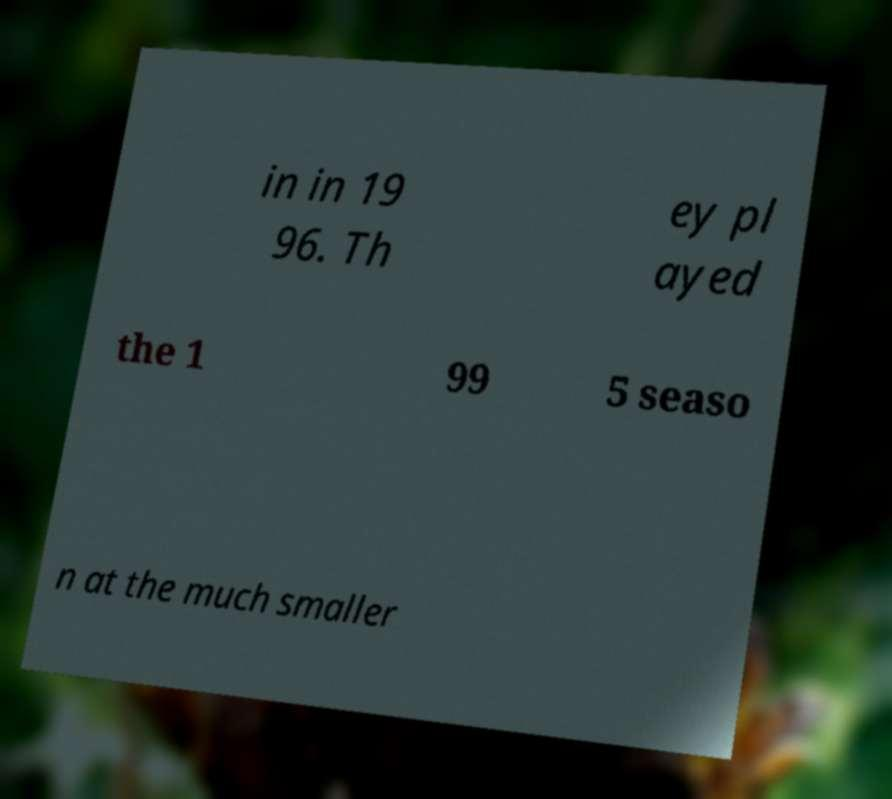Can you read and provide the text displayed in the image?This photo seems to have some interesting text. Can you extract and type it out for me? in in 19 96. Th ey pl ayed the 1 99 5 seaso n at the much smaller 